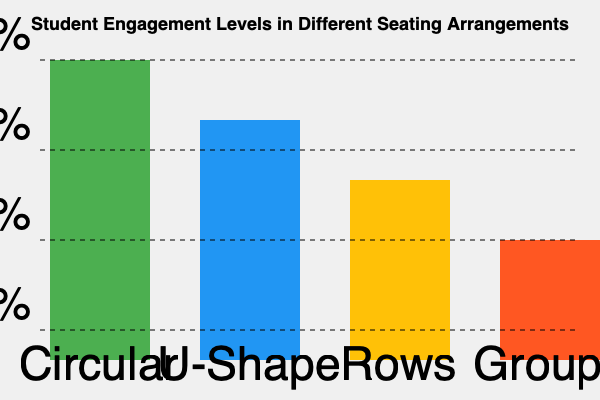Based on the graph showing student engagement levels in different seating arrangements, calculate the Engagement Effectiveness Index (EEI) using the formula: $EEI = \frac{\sum_{i=1}^{n} (E_i \times W_i)}{\sum_{i=1}^{n} W_i}$, where $E_i$ is the engagement level for each arrangement, and $W_i$ is the weight assigned based on the arrangement's rank (4 for highest, 1 for lowest). What conclusions can be drawn about the most effective seating arrangement for promoting student engagement in a preschool classroom? To calculate the Engagement Effectiveness Index (EEI), we'll follow these steps:

1. Identify engagement levels ($E_i$) from the graph:
   Circular: 100%
   U-Shape: 80%
   Rows: 60%
   Groups: 40%

2. Assign weights ($W_i$) based on rank:
   Circular: 4
   U-Shape: 3
   Rows: 2
   Groups: 1

3. Calculate $E_i \times W_i$ for each arrangement:
   Circular: 100% × 4 = 4.00
   U-Shape: 80% × 3 = 2.40
   Rows: 60% × 2 = 1.20
   Groups: 40% × 1 = 0.40

4. Sum $E_i \times W_i$ values:
   $\sum_{i=1}^{n} (E_i \times W_i) = 4.00 + 2.40 + 1.20 + 0.40 = 8.00$

5. Sum weights:
   $\sum_{i=1}^{n} W_i = 4 + 3 + 2 + 1 = 10$

6. Calculate EEI:
   $EEI = \frac{8.00}{10} = 0.80$ or 80%

Conclusions:
1. The circular seating arrangement is the most effective for promoting student engagement in a preschool classroom, with 100% engagement.
2. There is a clear trend of decreasing engagement as seating arrangements become less interactive (from circular to groups).
3. The EEI of 80% suggests that, overall, the seating arrangements are effective in promoting engagement, but there is room for improvement in less effective arrangements.
4. For preschool teachers applying scientific learning theories, this data supports the use of more interactive seating arrangements to maximize student engagement and facilitate collaborative learning experiences.
5. The significant difference between circular (100%) and group (40%) seating suggests that preschool teachers should carefully consider the impact of seating arrangements on their students' engagement levels.
Answer: Circular seating is most effective; EEI = 80%, indicating high overall effectiveness with room for improvement in less interactive arrangements. 